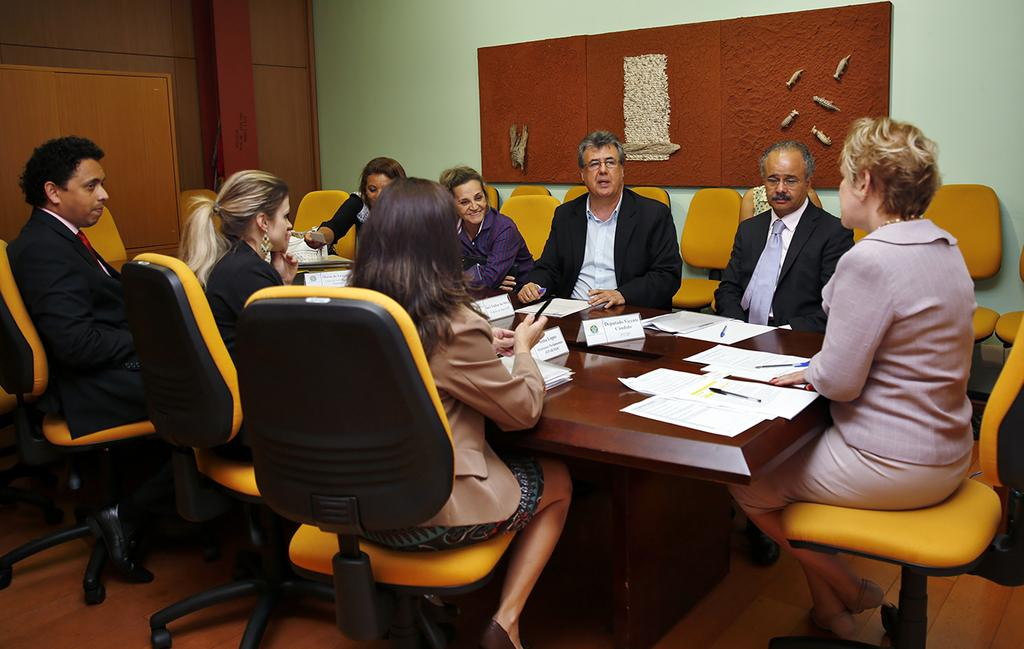What is present in the background of the image? There is a wall in the image. What are the people in the image doing? The people are sitting on chairs in the image. What is in front of the chairs? There is a table in front of the chairs. What is on the table? There is a poster, papers, and pens on the table. Can you tell me how many armies are present in the image? There are no armies present in the image. What is the name of the mom in the image? There is no mom present in the image. 